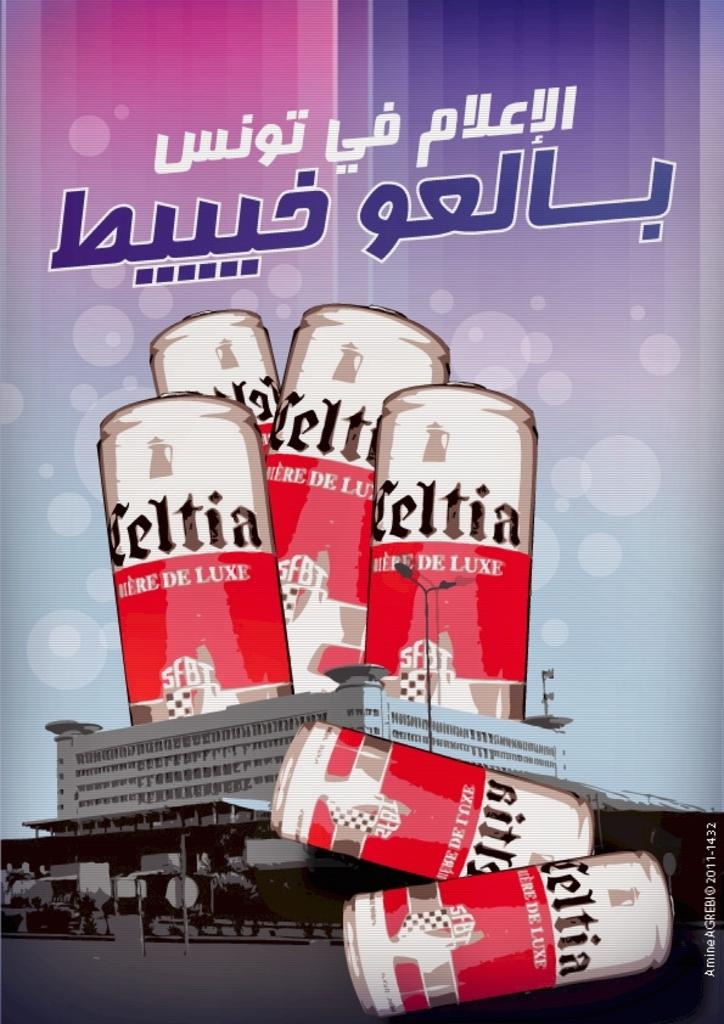<image>
Relay a brief, clear account of the picture shown. six stylized colored cans of Celtia branded beer. 